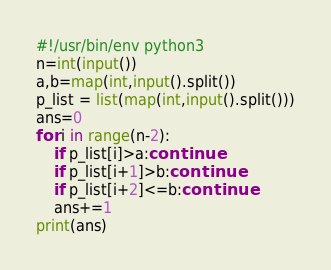<code> <loc_0><loc_0><loc_500><loc_500><_Python_>#!/usr/bin/env python3
n=int(input())
a,b=map(int,input().split())
p_list = list(map(int,input().split()))
ans=0
for i in range(n-2):
    if p_list[i]>a:continue
    if p_list[i+1]>b:continue
    if p_list[i+2]<=b:continue
    ans+=1
print(ans)
</code> 